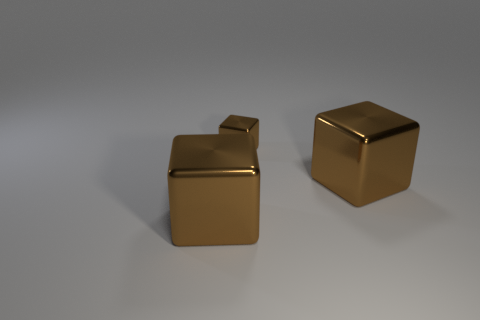There is a big brown object to the left of the large object to the right of the tiny shiny thing; are there any cubes to the right of it?
Your response must be concise. Yes. Is there a tiny brown metallic object?
Your answer should be compact. Yes. What is the size of the brown thing right of the brown shiny block that is behind the cube on the right side of the small thing?
Give a very brief answer. Large. The metallic object that is on the right side of the tiny metal block is what color?
Your response must be concise. Brown. Are there more small things right of the tiny brown cube than small brown metallic cubes?
Your answer should be compact. No. Is the shape of the brown metallic thing on the left side of the small shiny cube the same as  the tiny shiny thing?
Your answer should be compact. Yes. How many brown things are either large metallic things or small metallic blocks?
Offer a terse response. 3. Are there more small cubes than big cubes?
Your answer should be very brief. No. How many cubes are small brown metallic objects or large shiny things?
Provide a succinct answer. 3. Do the tiny brown thing and the big brown metallic thing right of the tiny thing have the same shape?
Make the answer very short. Yes. 